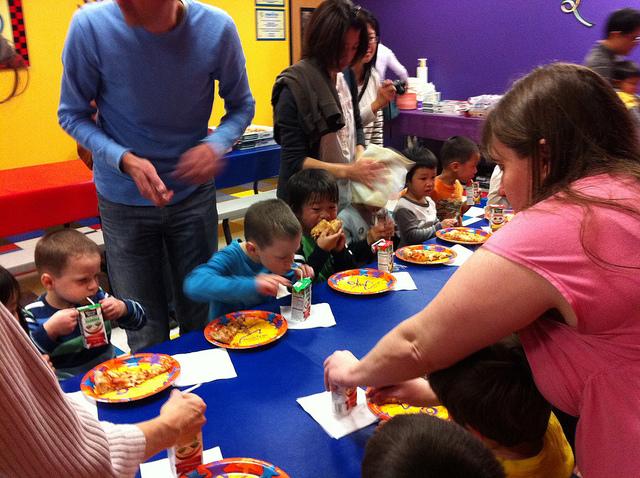Who is standing next to the little boy with the striped shirt?
Give a very brief answer. Man. What are the students drinking?
Write a very short answer. Juice. What number of plates are on the table?
Give a very brief answer. 7. 